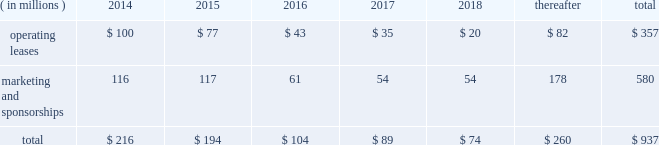Visa inc .
Notes to consolidated financial statements 2014 ( continued ) september 30 , 2013 market condition is based on the company 2019s total shareholder return ranked against that of other companies that are included in the standard & poor 2019s 500 index .
The fair value of the performance- based shares , incorporating the market condition , is estimated on the grant date using a monte carlo simulation model .
The grant-date fair value of performance-based shares in fiscal 2013 , 2012 and 2011 was $ 164.14 , $ 97.84 and $ 85.05 per share , respectively .
Earned performance shares granted in fiscal 2013 and 2012 vest approximately three years from the initial grant date .
Earned performance shares granted in fiscal 2011 vest in two equal installments approximately two and three years from their respective grant dates .
All performance awards are subject to earlier vesting in full under certain conditions .
Compensation cost for performance-based shares is initially estimated based on target performance .
It is recorded net of estimated forfeitures and adjusted as appropriate throughout the performance period .
At september 30 , 2013 , there was $ 15 million of total unrecognized compensation cost related to unvested performance-based shares , which is expected to be recognized over a weighted-average period of approximately 1.0 years .
Note 17 2014commitments and contingencies commitments .
The company leases certain premises and equipment throughout the world with varying expiration dates .
The company incurred total rent expense of $ 94 million , $ 89 million and $ 76 million in fiscal 2013 , 2012 and 2011 , respectively .
Future minimum payments on leases , and marketing and sponsorship agreements per fiscal year , at september 30 , 2013 , are as follows: .
Select sponsorship agreements require the company to spend certain minimum amounts for advertising and marketing promotion over the life of the contract .
For commitments where the individual years of spend are not specified in the contract , the company has estimated the timing of when these amounts will be spent .
In addition to the fixed payments stated above , select sponsorship agreements require the company to undertake marketing , promotional or other activities up to stated monetary values to support events which the company is sponsoring .
The stated monetary value of these activities typically represents the value in the marketplace , which may be significantly in excess of the actual costs incurred by the company .
Client incentives .
The company has agreements with financial institution clients and other business partners for various programs designed to build payments volume , increase visa-branded card and product acceptance and win merchant routing transactions .
These agreements , with original terms ranging from one to thirteen years , can provide card issuance and/or conversion support , volume/growth targets and marketing and program support based on specific performance requirements .
These agreements are designed to encourage client business and to increase overall visa-branded payment and transaction volume , thereby reducing per-unit transaction processing costs and increasing brand awareness for all visa clients .
Payments made that qualify for capitalization , and obligations incurred under these programs are reflected on the consolidated balance sheet .
Client incentives are recognized primarily as a reduction .
What will be the percentage increase in rent expense from 2013 to 2014? 
Computations: ((100 - 94) / 94)
Answer: 0.06383. 